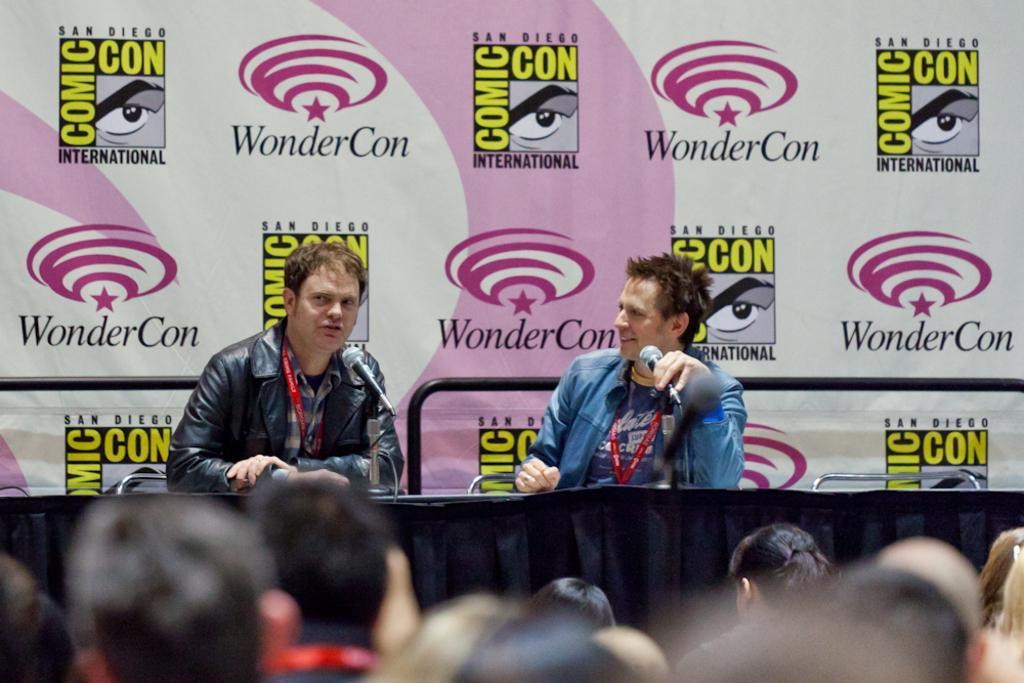Can you describe this image briefly? In this picture we can see a group of people. In front of them we can see two men, mics, cloth, chairs and a banner. 